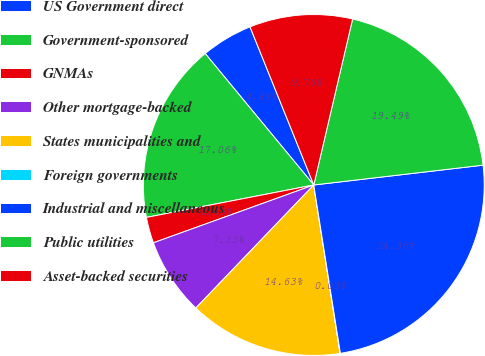<chart> <loc_0><loc_0><loc_500><loc_500><pie_chart><fcel>US Government direct<fcel>Government-sponsored<fcel>GNMAs<fcel>Other mortgage-backed<fcel>States municipalities and<fcel>Foreign governments<fcel>Industrial and miscellaneous<fcel>Public utilities<fcel>Asset-backed securities<nl><fcel>4.89%<fcel>17.06%<fcel>2.46%<fcel>7.33%<fcel>14.63%<fcel>0.03%<fcel>24.36%<fcel>19.49%<fcel>9.76%<nl></chart> 